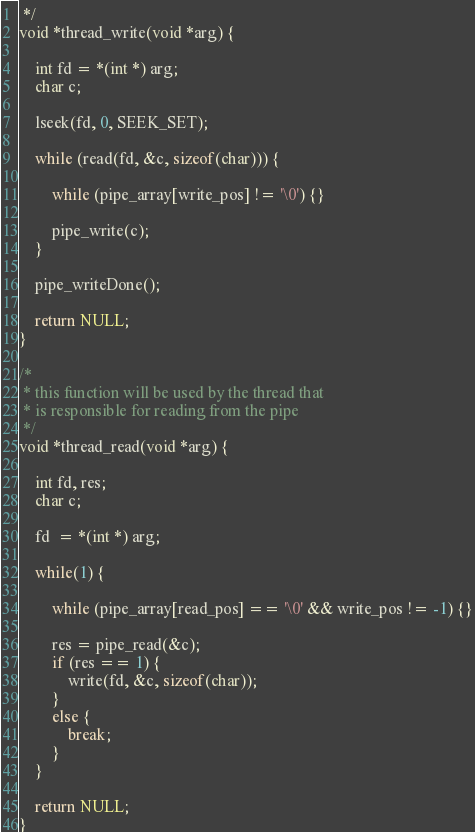<code> <loc_0><loc_0><loc_500><loc_500><_C_> */
void *thread_write(void *arg) {

    int fd = *(int *) arg;
    char c;
    
    lseek(fd, 0, SEEK_SET);

    while (read(fd, &c, sizeof(char))) {
        
        while (pipe_array[write_pos] != '\0') {}

        pipe_write(c);
    }

    pipe_writeDone();

    return NULL;
}

/*
 * this function will be used by the thread that
 * is responsible for reading from the pipe
 */
void *thread_read(void *arg) {

    int fd, res;
    char c;

    fd  = *(int *) arg;

    while(1) {

        while (pipe_array[read_pos] == '\0' && write_pos != -1) {}

        res = pipe_read(&c);
        if (res == 1) {
            write(fd, &c, sizeof(char));
        }
        else {
            break;
        }
    }

    return NULL;
}
</code> 